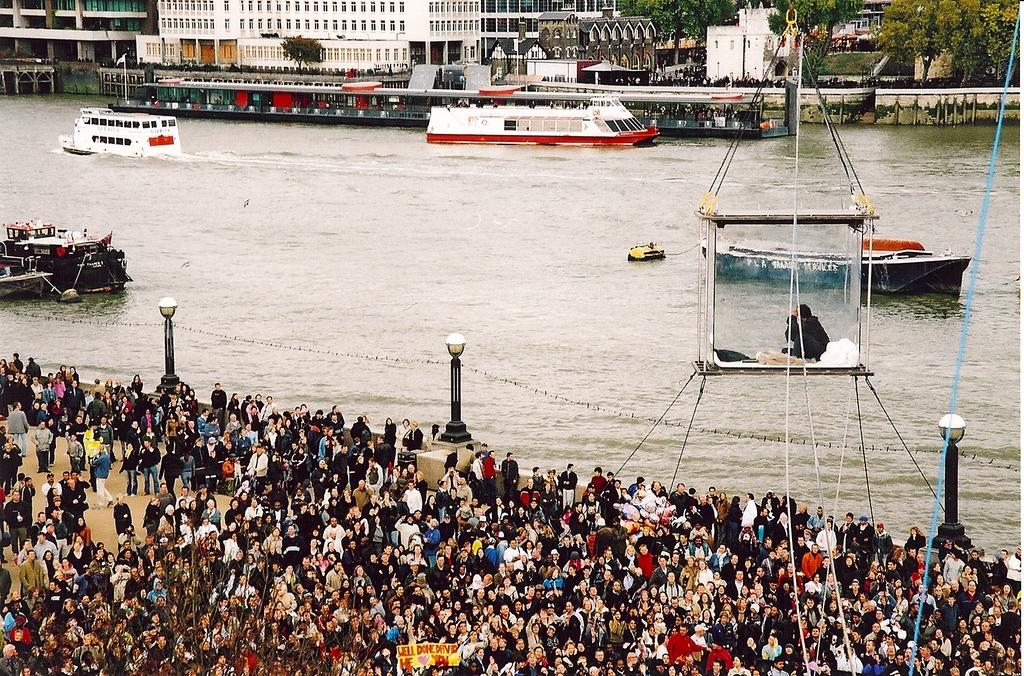How many people can be seen in the image? There are many people in the image. What is happening on the water in the image? There are ships sailing on the water in the image. What are the poles with lights used for in the image? The poles with lights are likely used for illumination or signaling purposes. What can be seen in the background of the image? There are buildings and trees visible in the background of the image. What invention is being demonstrated by the people in the image? There is no specific invention being demonstrated by the people in the image. How comfortable are the chairs on the ships in the image? The image does not provide enough detail to determine the comfort level of the chairs on the ships. 